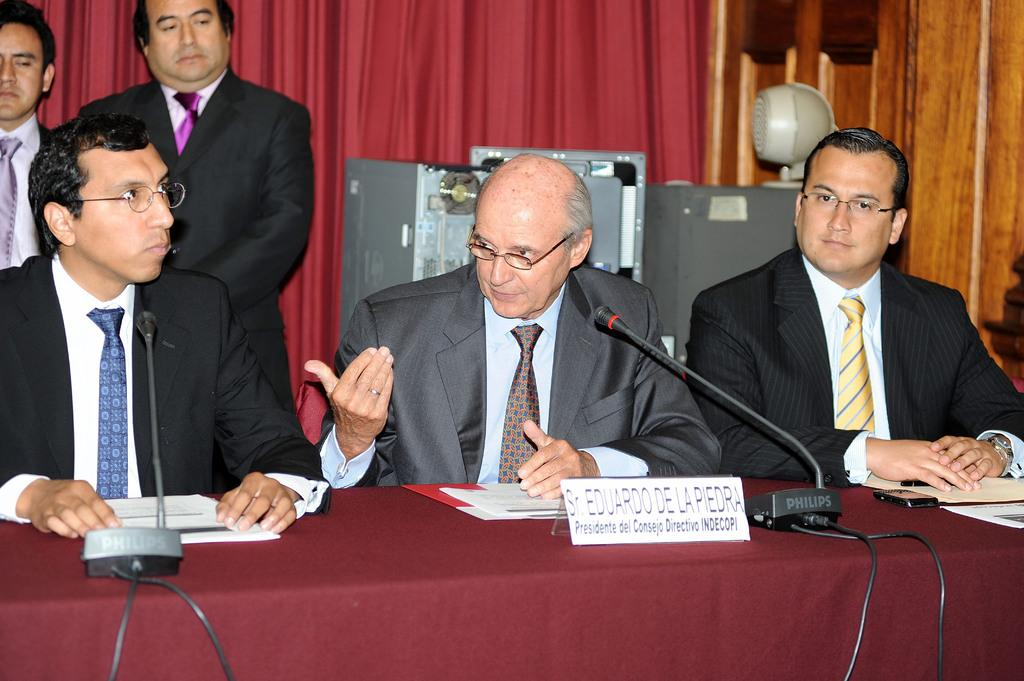How many people are sitting in the image? There are three persons sitting in the image. Are there any people standing in the image? Yes, on the left side, there are two persons standing. What can be seen in the background of the image? There is a wall in the background of the image, and a curtain is on the wall. What type of vacation is the group planning in the image? There is no indication of a vacation or any planning in the image. 